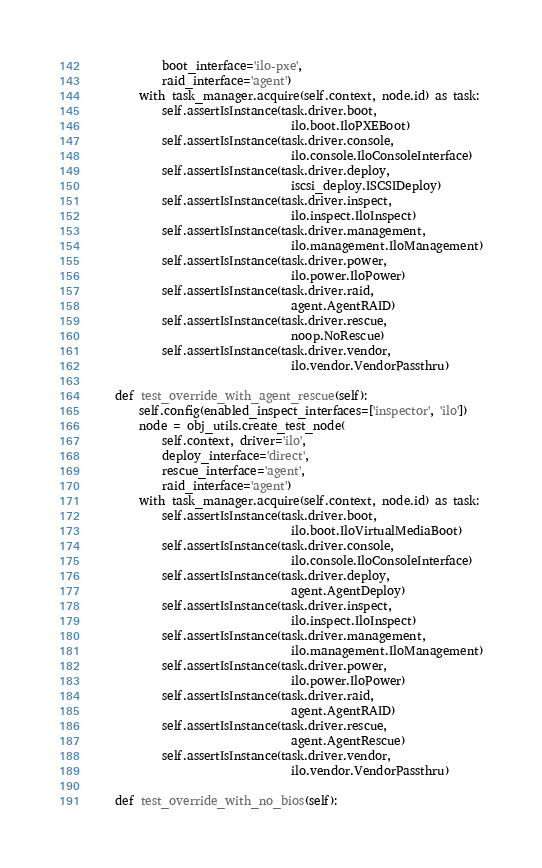Convert code to text. <code><loc_0><loc_0><loc_500><loc_500><_Python_>            boot_interface='ilo-pxe',
            raid_interface='agent')
        with task_manager.acquire(self.context, node.id) as task:
            self.assertIsInstance(task.driver.boot,
                                  ilo.boot.IloPXEBoot)
            self.assertIsInstance(task.driver.console,
                                  ilo.console.IloConsoleInterface)
            self.assertIsInstance(task.driver.deploy,
                                  iscsi_deploy.ISCSIDeploy)
            self.assertIsInstance(task.driver.inspect,
                                  ilo.inspect.IloInspect)
            self.assertIsInstance(task.driver.management,
                                  ilo.management.IloManagement)
            self.assertIsInstance(task.driver.power,
                                  ilo.power.IloPower)
            self.assertIsInstance(task.driver.raid,
                                  agent.AgentRAID)
            self.assertIsInstance(task.driver.rescue,
                                  noop.NoRescue)
            self.assertIsInstance(task.driver.vendor,
                                  ilo.vendor.VendorPassthru)

    def test_override_with_agent_rescue(self):
        self.config(enabled_inspect_interfaces=['inspector', 'ilo'])
        node = obj_utils.create_test_node(
            self.context, driver='ilo',
            deploy_interface='direct',
            rescue_interface='agent',
            raid_interface='agent')
        with task_manager.acquire(self.context, node.id) as task:
            self.assertIsInstance(task.driver.boot,
                                  ilo.boot.IloVirtualMediaBoot)
            self.assertIsInstance(task.driver.console,
                                  ilo.console.IloConsoleInterface)
            self.assertIsInstance(task.driver.deploy,
                                  agent.AgentDeploy)
            self.assertIsInstance(task.driver.inspect,
                                  ilo.inspect.IloInspect)
            self.assertIsInstance(task.driver.management,
                                  ilo.management.IloManagement)
            self.assertIsInstance(task.driver.power,
                                  ilo.power.IloPower)
            self.assertIsInstance(task.driver.raid,
                                  agent.AgentRAID)
            self.assertIsInstance(task.driver.rescue,
                                  agent.AgentRescue)
            self.assertIsInstance(task.driver.vendor,
                                  ilo.vendor.VendorPassthru)

    def test_override_with_no_bios(self):</code> 